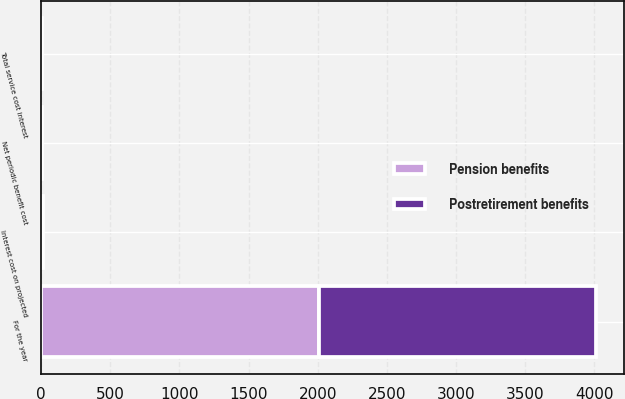<chart> <loc_0><loc_0><loc_500><loc_500><stacked_bar_chart><ecel><fcel>For the year<fcel>Interest cost on projected<fcel>Total service cost interest<fcel>Net periodic benefit cost<nl><fcel>Postretirement benefits<fcel>2008<fcel>11.9<fcel>5<fcel>6.2<nl><fcel>Pension benefits<fcel>2008<fcel>0.8<fcel>0.8<fcel>0.8<nl></chart> 